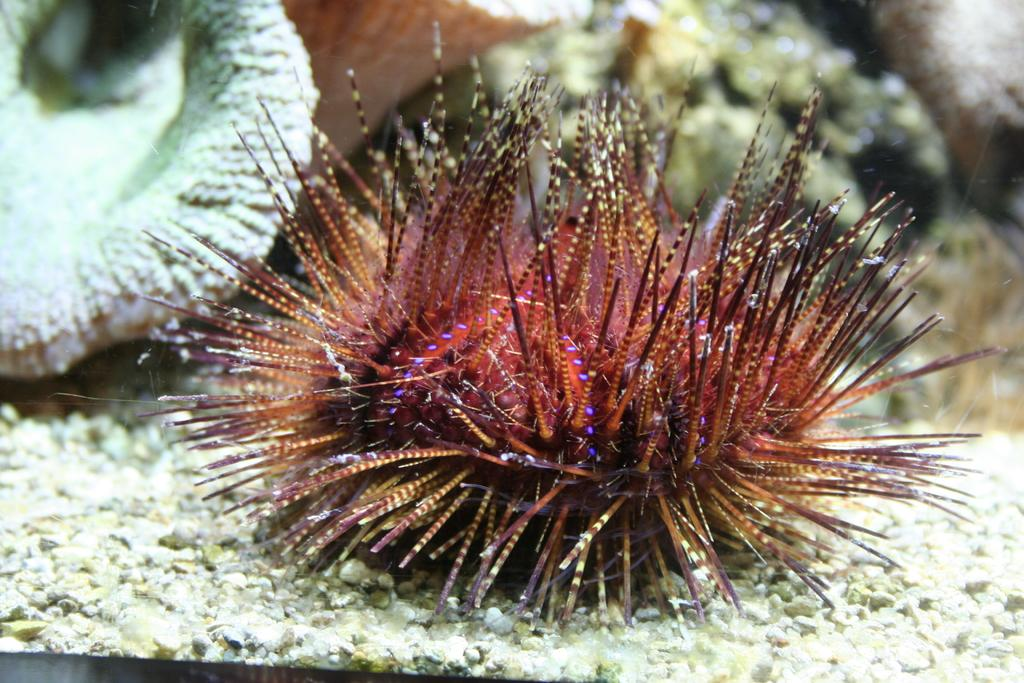What subject matter is the image related to? The image is related to marine biology. What type of cloth is being sold in the marine biology shop in the image? There is no shop or cloth present in the image, as it is related to marine biology and not a retail environment. 